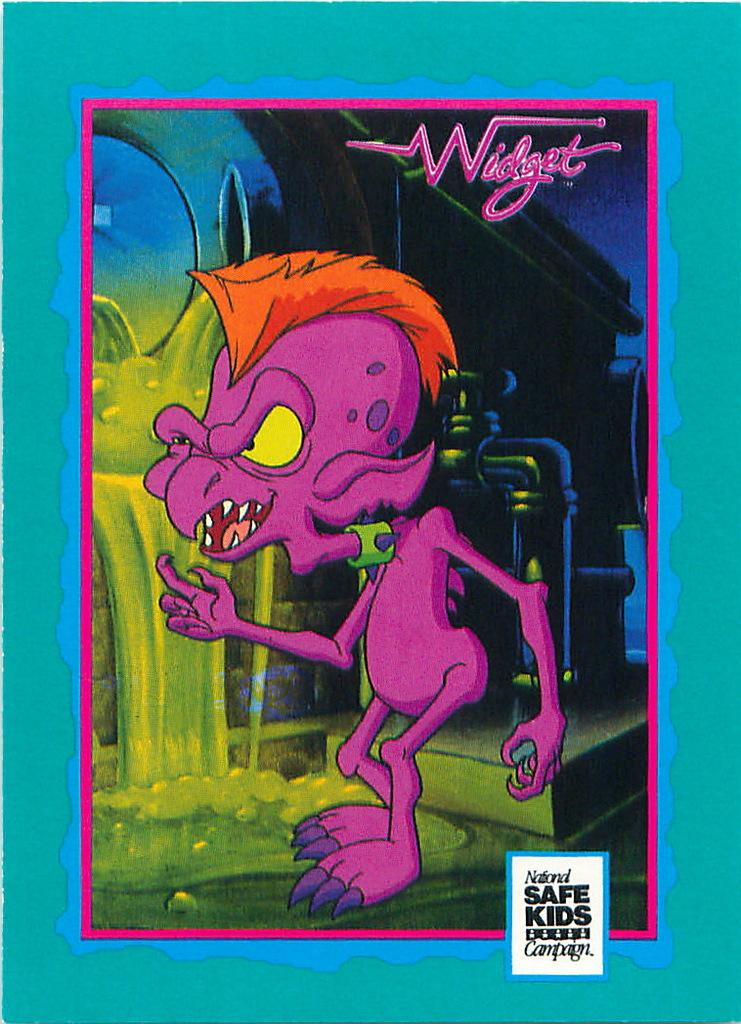<image>
Provide a brief description of the given image. A purple cartoon creature for the National Safe Kids Campaign. 